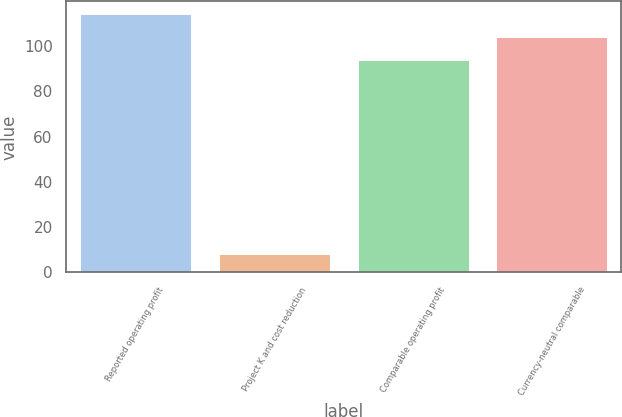Convert chart. <chart><loc_0><loc_0><loc_500><loc_500><bar_chart><fcel>Reported operating profit<fcel>Project K and cost reduction<fcel>Comparable operating profit<fcel>Currency-neutral comparable<nl><fcel>114<fcel>8<fcel>94<fcel>104<nl></chart> 